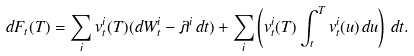<formula> <loc_0><loc_0><loc_500><loc_500>d F _ { t } ( T ) = \sum _ { i } v ^ { i } _ { t } ( T ) ( d W ^ { i } _ { t } - \lambda ^ { i } \, d t ) + \sum _ { i } \left ( v ^ { i } _ { t } ( T ) \int _ { t } ^ { T } v ^ { i } _ { t } ( u ) \, d u \right ) \, d t .</formula> 